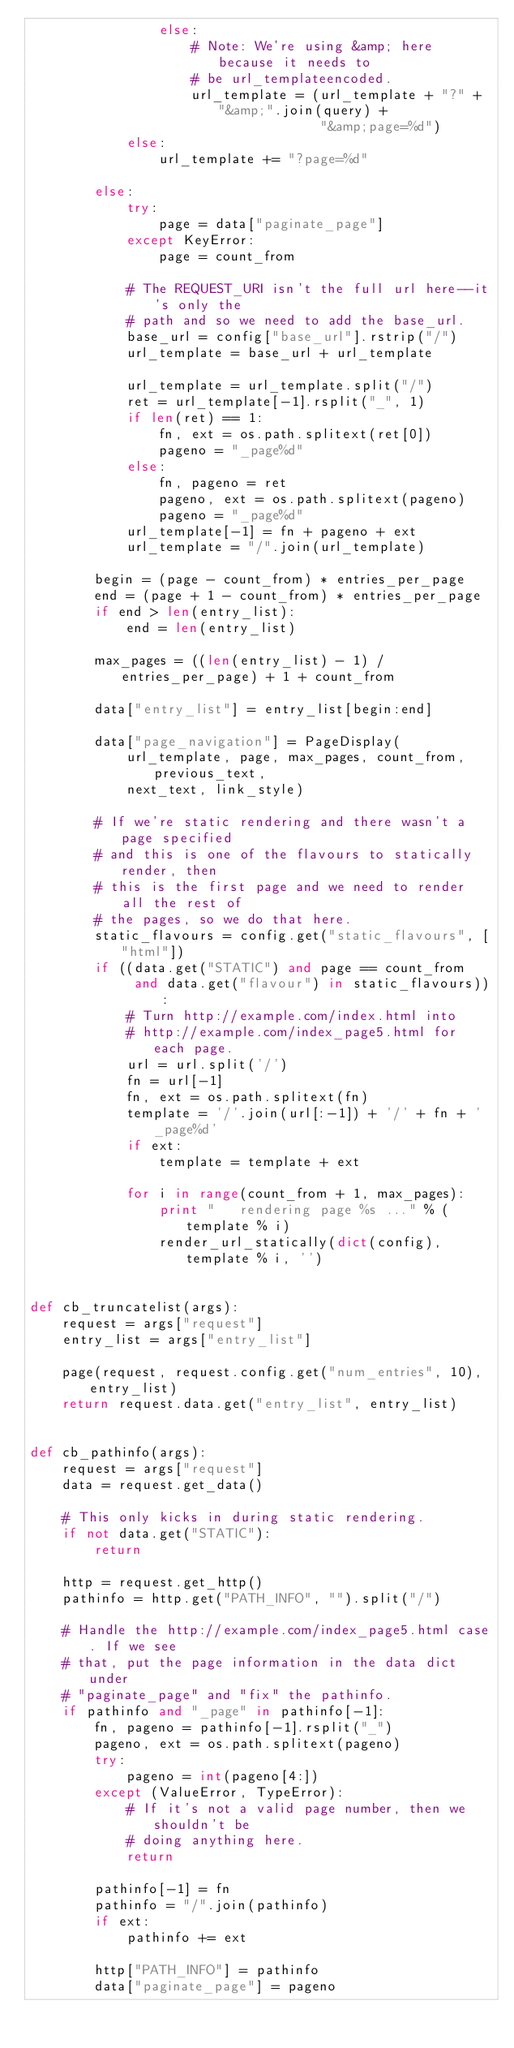Convert code to text. <code><loc_0><loc_0><loc_500><loc_500><_Python_>                else:
                    # Note: We're using &amp; here because it needs to
                    # be url_templateencoded.
                    url_template = (url_template + "?" + "&amp;".join(query) +
                                    "&amp;page=%d")
            else:
                url_template += "?page=%d"

        else:
            try:
                page = data["paginate_page"]
            except KeyError:
                page = count_from

            # The REQUEST_URI isn't the full url here--it's only the
            # path and so we need to add the base_url.
            base_url = config["base_url"].rstrip("/")
            url_template = base_url + url_template

            url_template = url_template.split("/")
            ret = url_template[-1].rsplit("_", 1)
            if len(ret) == 1:
                fn, ext = os.path.splitext(ret[0])
                pageno = "_page%d"
            else:
                fn, pageno = ret
                pageno, ext = os.path.splitext(pageno)
                pageno = "_page%d"
            url_template[-1] = fn + pageno + ext
            url_template = "/".join(url_template)

        begin = (page - count_from) * entries_per_page
        end = (page + 1 - count_from) * entries_per_page
        if end > len(entry_list):
            end = len(entry_list)

        max_pages = ((len(entry_list) - 1) / entries_per_page) + 1 + count_from

        data["entry_list"] = entry_list[begin:end]

        data["page_navigation"] = PageDisplay(
            url_template, page, max_pages, count_from, previous_text,
            next_text, link_style)

        # If we're static rendering and there wasn't a page specified
        # and this is one of the flavours to statically render, then
        # this is the first page and we need to render all the rest of
        # the pages, so we do that here.
        static_flavours = config.get("static_flavours", ["html"])
        if ((data.get("STATIC") and page == count_from
             and data.get("flavour") in static_flavours)):
            # Turn http://example.com/index.html into
            # http://example.com/index_page5.html for each page.
            url = url.split('/')
            fn = url[-1]
            fn, ext = os.path.splitext(fn)
            template = '/'.join(url[:-1]) + '/' + fn + '_page%d'
            if ext:
                template = template + ext

            for i in range(count_from + 1, max_pages):
                print "   rendering page %s ..." % (template % i)
                render_url_statically(dict(config), template % i, '')


def cb_truncatelist(args):
    request = args["request"]
    entry_list = args["entry_list"]

    page(request, request.config.get("num_entries", 10), entry_list)
    return request.data.get("entry_list", entry_list)


def cb_pathinfo(args):
    request = args["request"]
    data = request.get_data()

    # This only kicks in during static rendering.
    if not data.get("STATIC"):
        return

    http = request.get_http()
    pathinfo = http.get("PATH_INFO", "").split("/")

    # Handle the http://example.com/index_page5.html case. If we see
    # that, put the page information in the data dict under
    # "paginate_page" and "fix" the pathinfo.
    if pathinfo and "_page" in pathinfo[-1]:
        fn, pageno = pathinfo[-1].rsplit("_")
        pageno, ext = os.path.splitext(pageno)
        try:
            pageno = int(pageno[4:])
        except (ValueError, TypeError):
            # If it's not a valid page number, then we shouldn't be
            # doing anything here.
            return

        pathinfo[-1] = fn
        pathinfo = "/".join(pathinfo)
        if ext:
            pathinfo += ext

        http["PATH_INFO"] = pathinfo
        data["paginate_page"] = pageno
</code> 